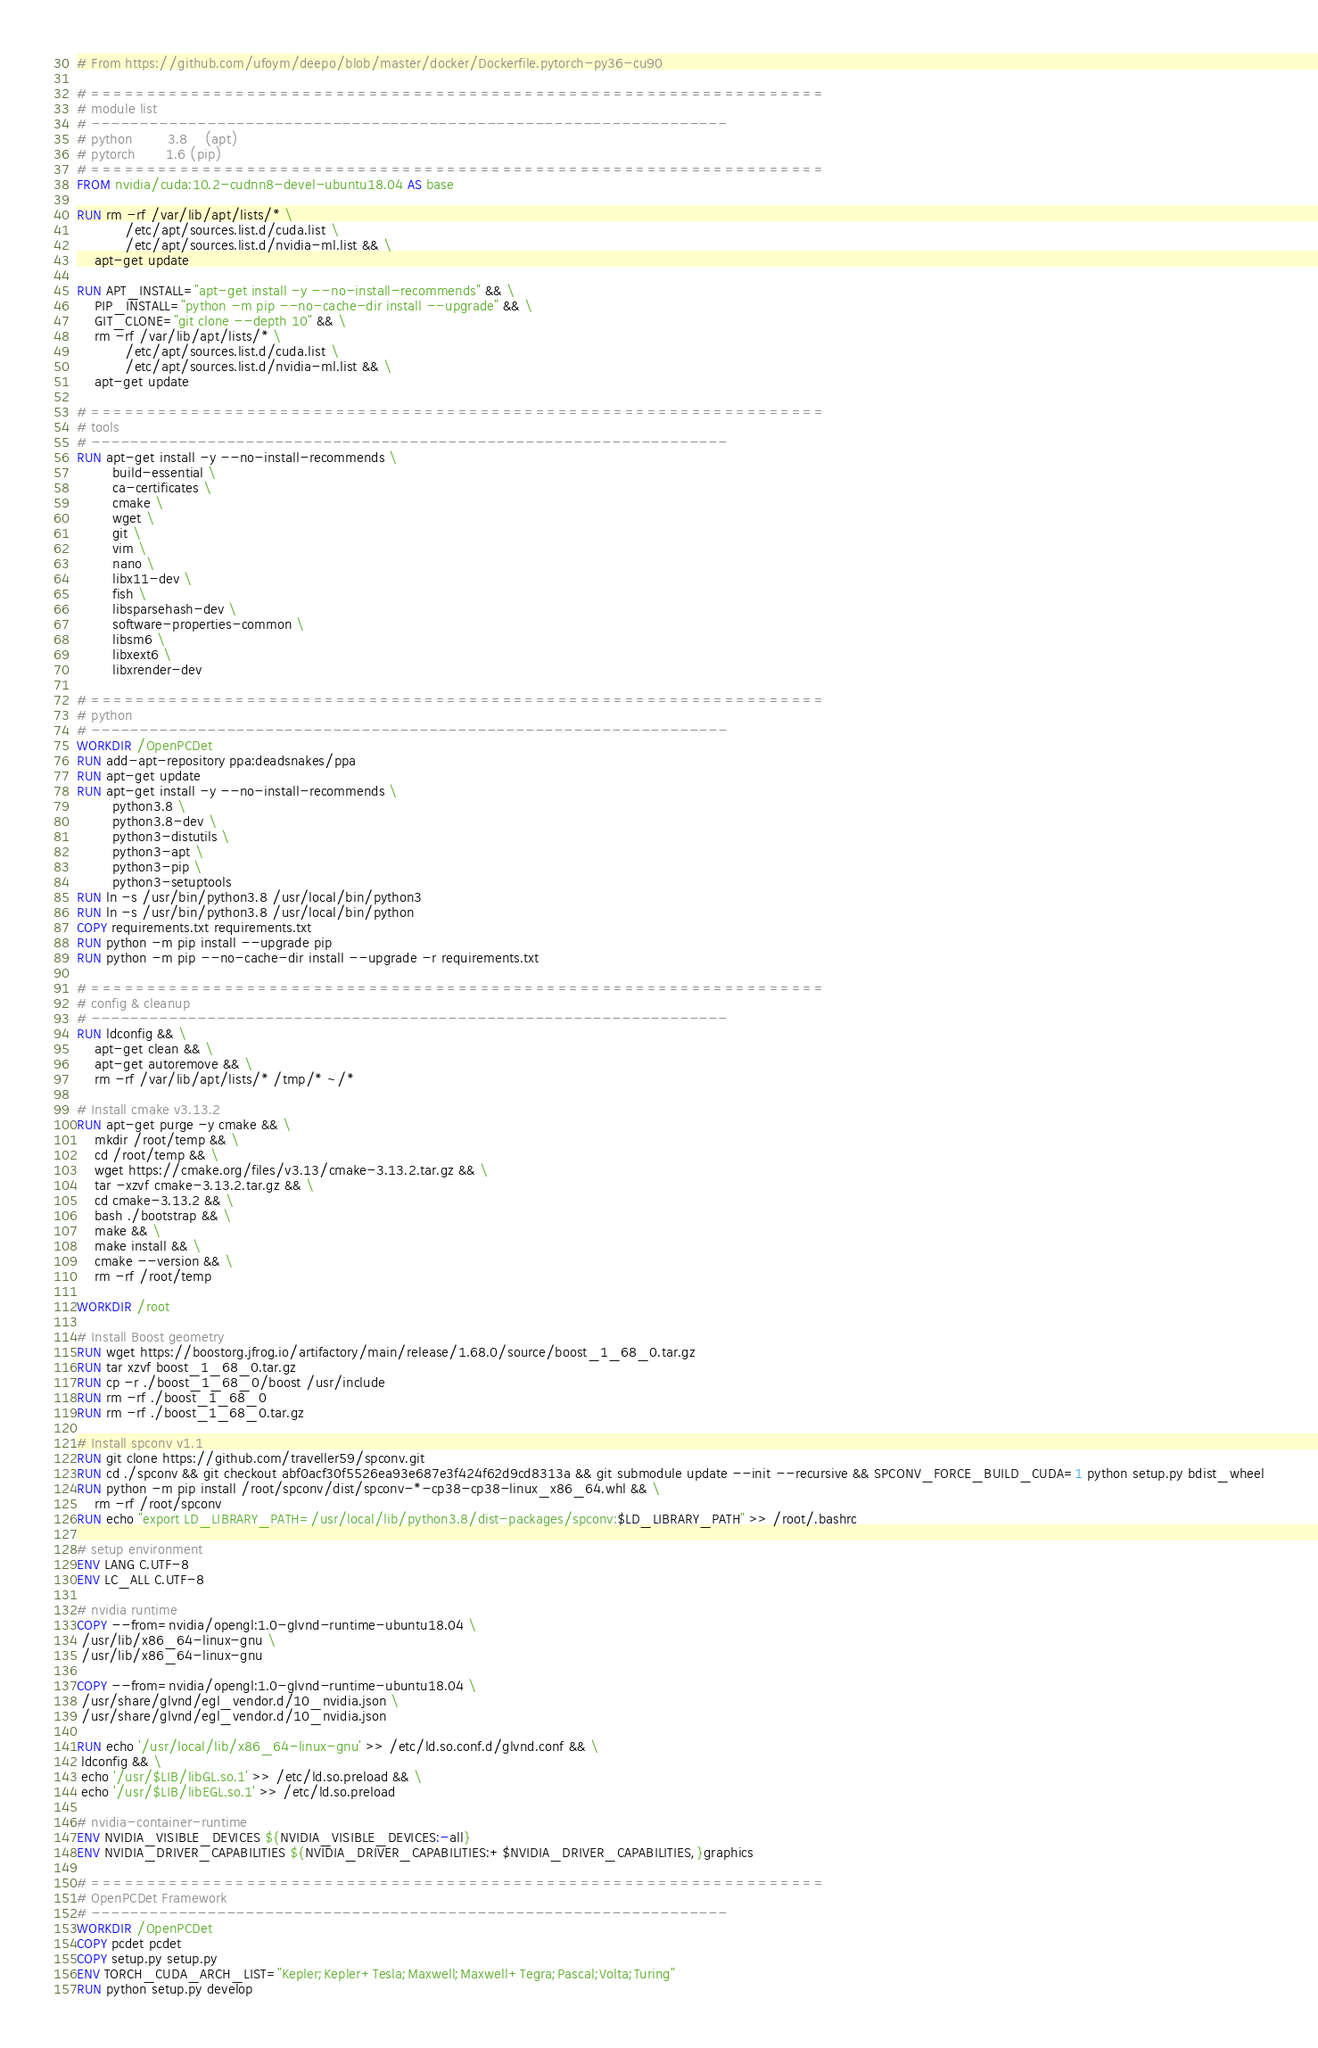<code> <loc_0><loc_0><loc_500><loc_500><_Dockerfile_># From https://github.com/ufoym/deepo/blob/master/docker/Dockerfile.pytorch-py36-cu90

# ==================================================================
# module list
# ------------------------------------------------------------------
# python        3.8    (apt)
# pytorch       1.6 (pip)
# ==================================================================
FROM nvidia/cuda:10.2-cudnn8-devel-ubuntu18.04 AS base

RUN rm -rf /var/lib/apt/lists/* \
           /etc/apt/sources.list.d/cuda.list \
           /etc/apt/sources.list.d/nvidia-ml.list && \
    apt-get update

RUN APT_INSTALL="apt-get install -y --no-install-recommends" && \
    PIP_INSTALL="python -m pip --no-cache-dir install --upgrade" && \
    GIT_CLONE="git clone --depth 10" && \
    rm -rf /var/lib/apt/lists/* \
           /etc/apt/sources.list.d/cuda.list \
           /etc/apt/sources.list.d/nvidia-ml.list && \
    apt-get update

# ==================================================================
# tools
# ------------------------------------------------------------------
RUN apt-get install -y --no-install-recommends \
        build-essential \
        ca-certificates \
        cmake \
        wget \
        git \
        vim \
	    nano \
        libx11-dev \
        fish \
        libsparsehash-dev \
        software-properties-common \
        libsm6 \
        libxext6 \
        libxrender-dev

# ==================================================================
# python
# ------------------------------------------------------------------
WORKDIR /OpenPCDet
RUN add-apt-repository ppa:deadsnakes/ppa
RUN apt-get update
RUN apt-get install -y --no-install-recommends \
        python3.8 \
        python3.8-dev \
        python3-distutils \
        python3-apt \
        python3-pip \
        python3-setuptools
RUN ln -s /usr/bin/python3.8 /usr/local/bin/python3
RUN ln -s /usr/bin/python3.8 /usr/local/bin/python
COPY requirements.txt requirements.txt
RUN python -m pip install --upgrade pip
RUN python -m pip --no-cache-dir install --upgrade -r requirements.txt

# ==================================================================
# config & cleanup
# ------------------------------------------------------------------
RUN ldconfig && \
    apt-get clean && \
    apt-get autoremove && \
    rm -rf /var/lib/apt/lists/* /tmp/* ~/*

# Install cmake v3.13.2
RUN apt-get purge -y cmake && \
    mkdir /root/temp && \
    cd /root/temp && \
    wget https://cmake.org/files/v3.13/cmake-3.13.2.tar.gz && \
    tar -xzvf cmake-3.13.2.tar.gz && \
    cd cmake-3.13.2 && \
    bash ./bootstrap && \
    make && \
    make install && \
    cmake --version && \
    rm -rf /root/temp

WORKDIR /root

# Install Boost geometry
RUN wget https://boostorg.jfrog.io/artifactory/main/release/1.68.0/source/boost_1_68_0.tar.gz
RUN tar xzvf boost_1_68_0.tar.gz
RUN cp -r ./boost_1_68_0/boost /usr/include
RUN rm -rf ./boost_1_68_0
RUN rm -rf ./boost_1_68_0.tar.gz

# Install spconv v1.1
RUN git clone https://github.com/traveller59/spconv.git
RUN cd ./spconv && git checkout abf0acf30f5526ea93e687e3f424f62d9cd8313a && git submodule update --init --recursive && SPCONV_FORCE_BUILD_CUDA=1 python setup.py bdist_wheel
RUN python -m pip install /root/spconv/dist/spconv-*-cp38-cp38-linux_x86_64.whl && \
    rm -rf /root/spconv
RUN echo "export LD_LIBRARY_PATH=/usr/local/lib/python3.8/dist-packages/spconv:$LD_LIBRARY_PATH" >> /root/.bashrc

# setup environment
ENV LANG C.UTF-8
ENV LC_ALL C.UTF-8

# nvidia runtime
COPY --from=nvidia/opengl:1.0-glvnd-runtime-ubuntu18.04 \
 /usr/lib/x86_64-linux-gnu \
 /usr/lib/x86_64-linux-gnu

COPY --from=nvidia/opengl:1.0-glvnd-runtime-ubuntu18.04 \
 /usr/share/glvnd/egl_vendor.d/10_nvidia.json \
 /usr/share/glvnd/egl_vendor.d/10_nvidia.json

RUN echo '/usr/local/lib/x86_64-linux-gnu' >> /etc/ld.so.conf.d/glvnd.conf && \
 ldconfig && \
 echo '/usr/$LIB/libGL.so.1' >> /etc/ld.so.preload && \
 echo '/usr/$LIB/libEGL.so.1' >> /etc/ld.so.preload

# nvidia-container-runtime
ENV NVIDIA_VISIBLE_DEVICES ${NVIDIA_VISIBLE_DEVICES:-all}
ENV NVIDIA_DRIVER_CAPABILITIES ${NVIDIA_DRIVER_CAPABILITIES:+$NVIDIA_DRIVER_CAPABILITIES,}graphics

# ==================================================================
# OpenPCDet Framework
# ------------------------------------------------------------------
WORKDIR /OpenPCDet
COPY pcdet pcdet
COPY setup.py setup.py
ENV TORCH_CUDA_ARCH_LIST="Kepler;Kepler+Tesla;Maxwell;Maxwell+Tegra;Pascal;Volta;Turing"
RUN python setup.py develop</code> 